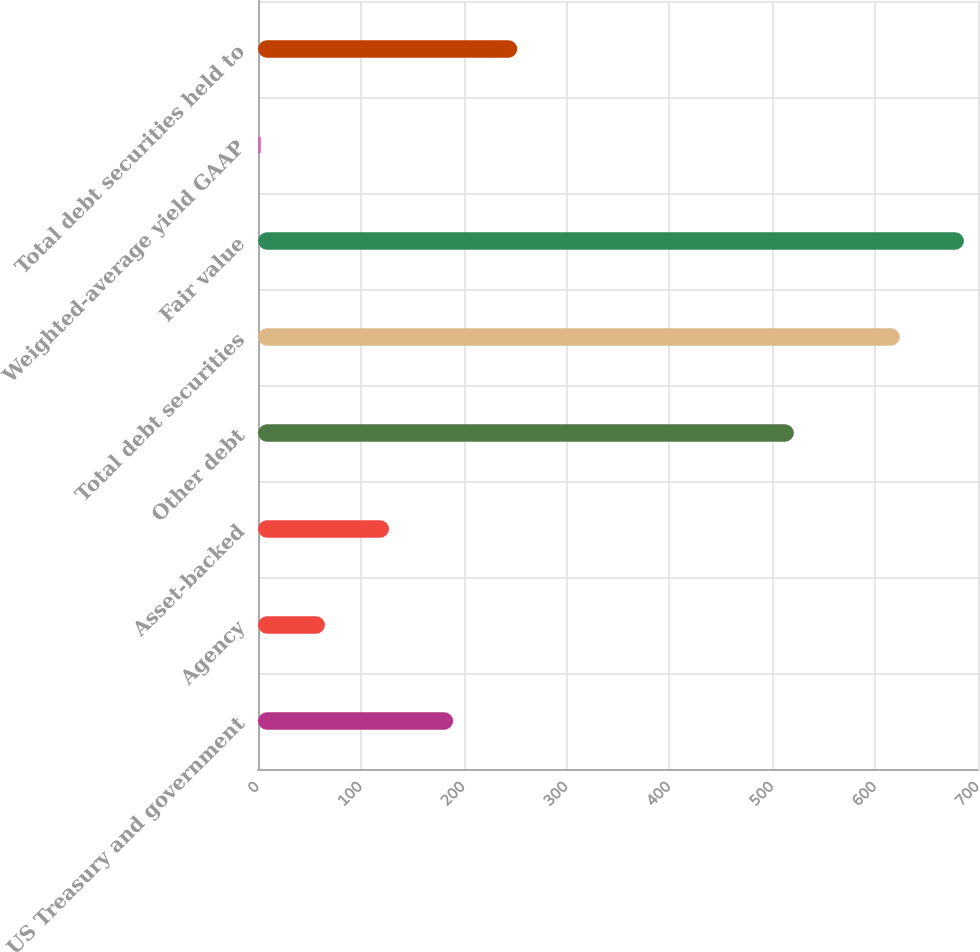<chart> <loc_0><loc_0><loc_500><loc_500><bar_chart><fcel>US Treasury and government<fcel>Agency<fcel>Asset-backed<fcel>Other debt<fcel>Total debt securities<fcel>Fair value<fcel>Weighted-average yield GAAP<fcel>Total debt securities held to<nl><fcel>189.72<fcel>65.06<fcel>127.39<fcel>521<fcel>624<fcel>686.33<fcel>2.73<fcel>252.05<nl></chart> 